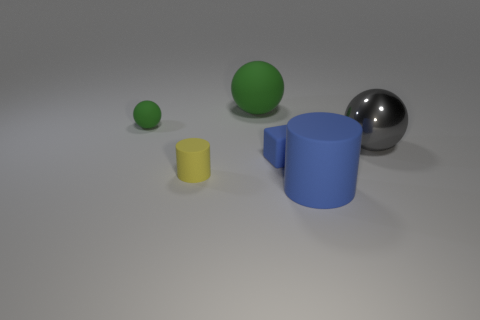Can you describe the colors of the objects starting from the left? Certainly! From the left, the first object is a small yellow cylinder, followed by a medium-sized green sphere, then a large blue cylinder, and finally, a large gray sphere on the right. 